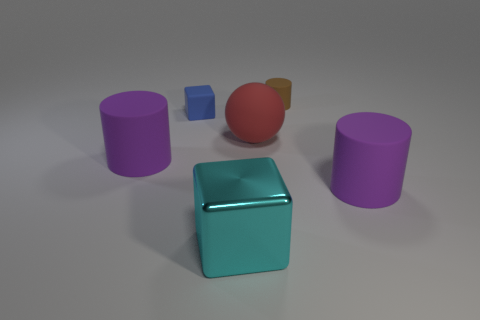Subtract all blue cylinders. Subtract all red blocks. How many cylinders are left? 3 Add 3 blue metal things. How many objects exist? 9 Subtract all cubes. How many objects are left? 4 Subtract all brown cylinders. Subtract all balls. How many objects are left? 4 Add 3 purple matte cylinders. How many purple matte cylinders are left? 5 Add 3 small red metallic things. How many small red metallic things exist? 3 Subtract 0 gray cylinders. How many objects are left? 6 